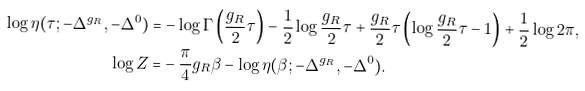Convert formula to latex. <formula><loc_0><loc_0><loc_500><loc_500>\log \eta ( \tau ; - \Delta ^ { g _ { R } } , - \Delta ^ { 0 } ) = & - \log \Gamma \left ( \frac { g _ { R } } { 2 } \tau \right ) - \frac { 1 } { 2 } \log \frac { g _ { R } } { 2 } \tau + \frac { g _ { R } } { 2 } \tau \left ( \log \frac { g _ { R } } { 2 } \tau - 1 \right ) + \frac { 1 } { 2 } \log 2 \pi , \\ \log Z = & - \frac { \pi } { 4 } g _ { R } \beta - \log \eta ( \beta ; - \Delta ^ { g _ { R } } , - \Delta ^ { 0 } ) . \\</formula> 